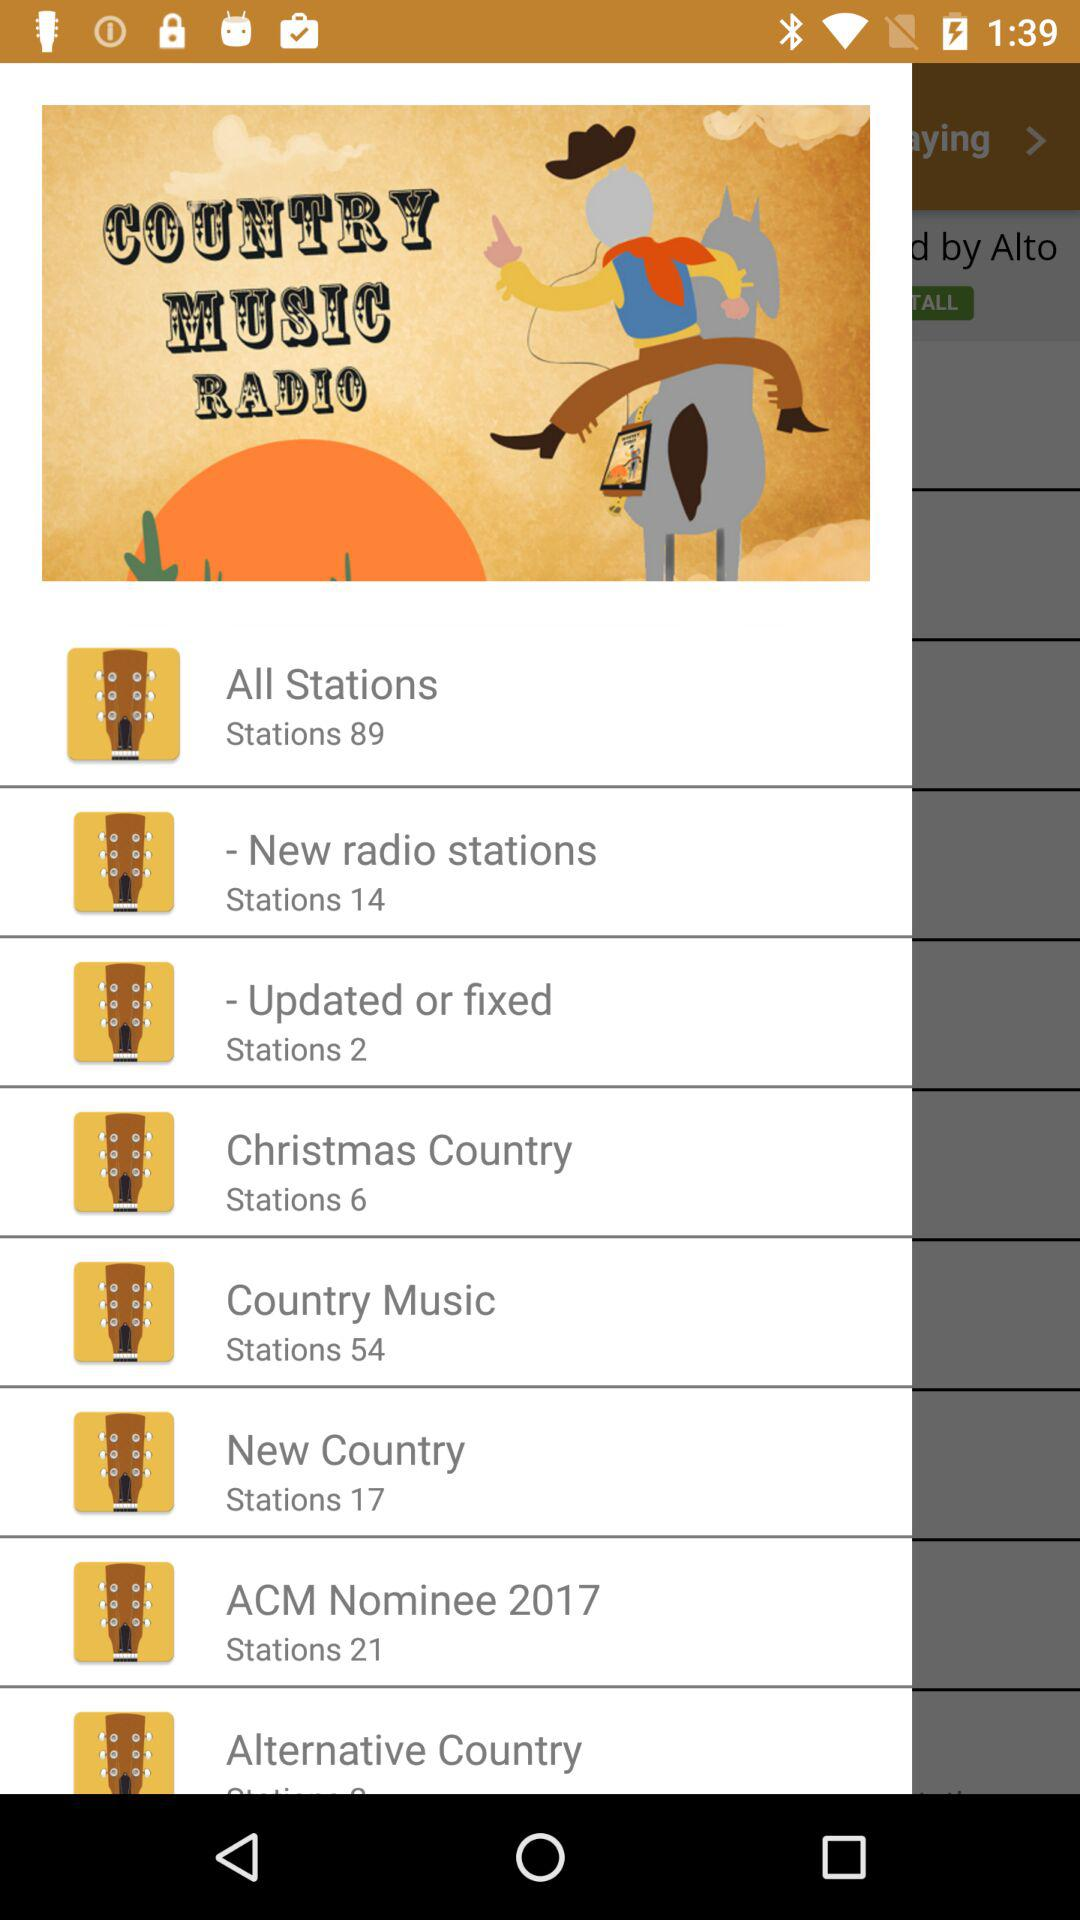How many stations in total are there in "All Stations"? There are total 89 stations in "All Stations". 